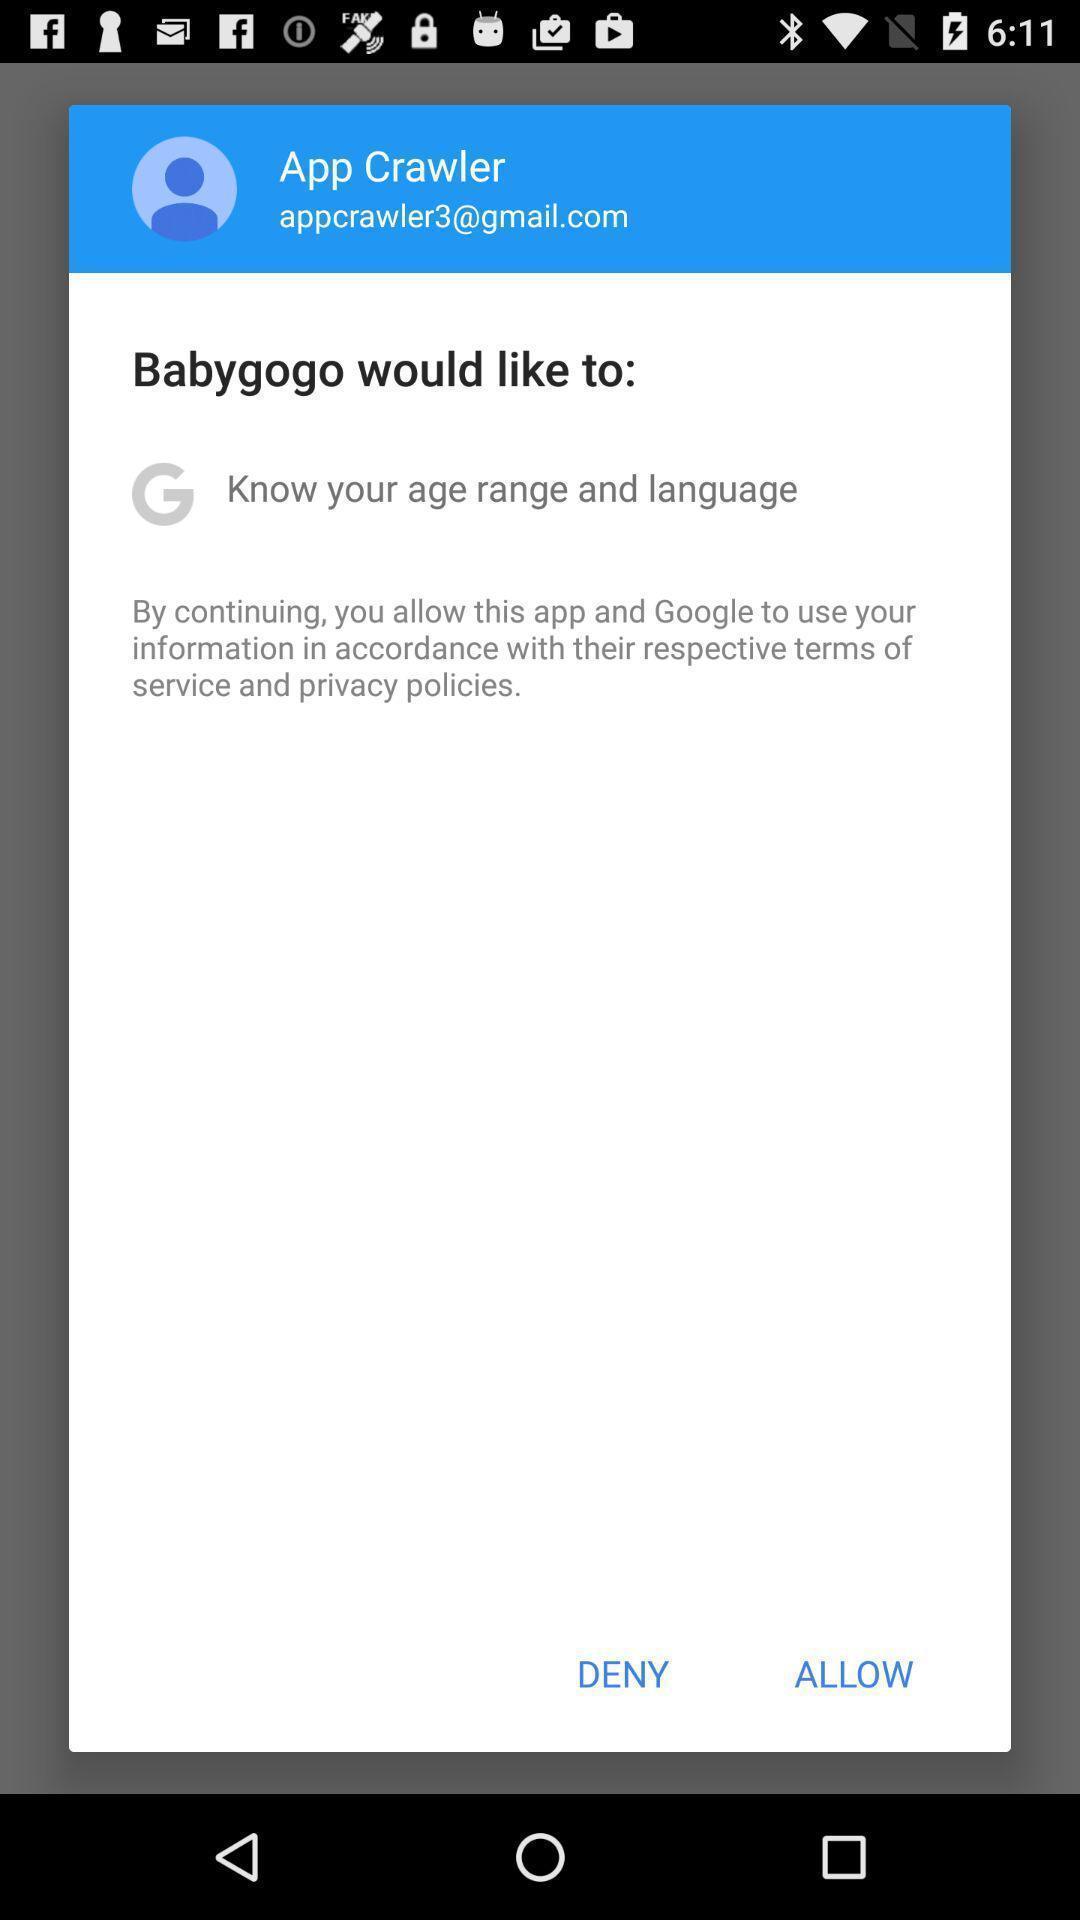Explain what's happening in this screen capture. Pop-up asking for an agreement on a pregnancy app. 